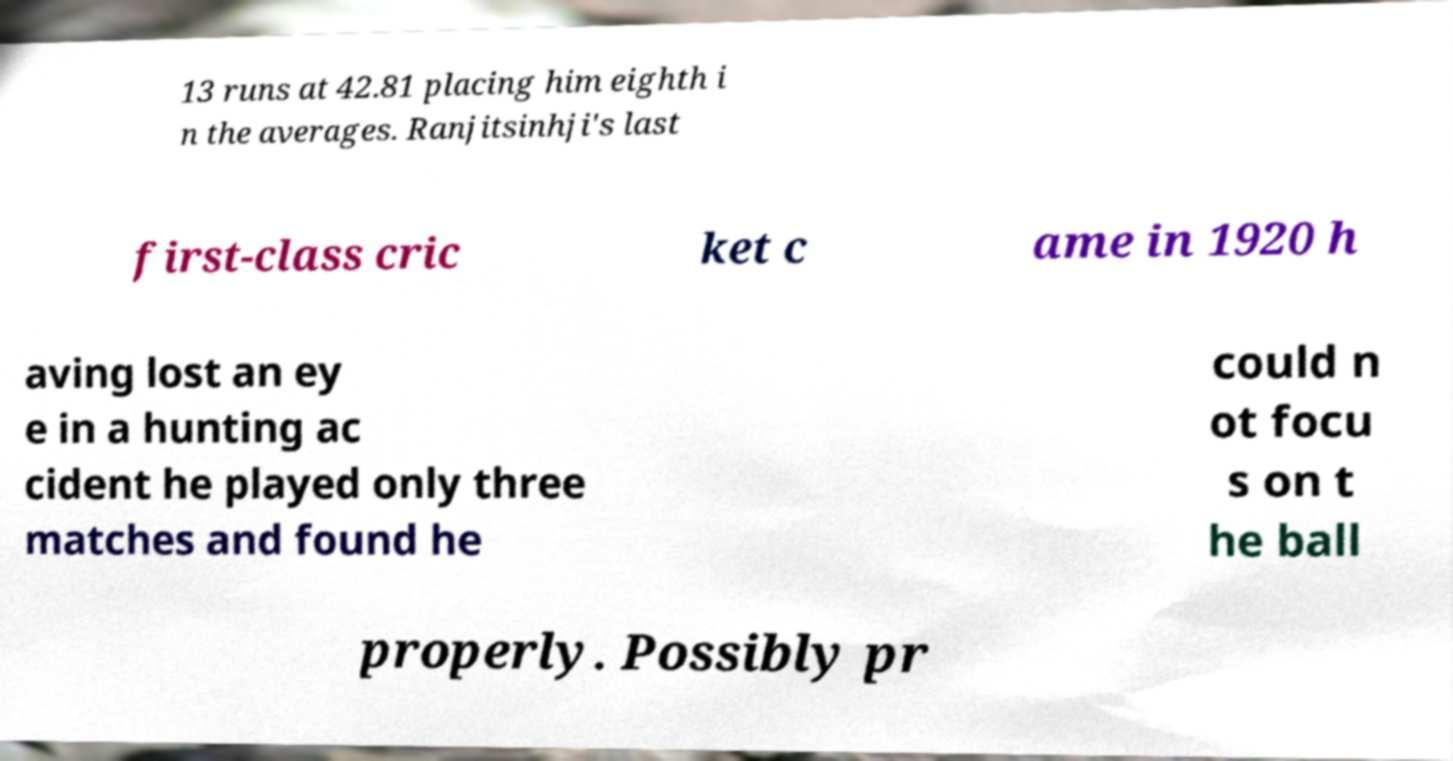Could you extract and type out the text from this image? 13 runs at 42.81 placing him eighth i n the averages. Ranjitsinhji's last first-class cric ket c ame in 1920 h aving lost an ey e in a hunting ac cident he played only three matches and found he could n ot focu s on t he ball properly. Possibly pr 